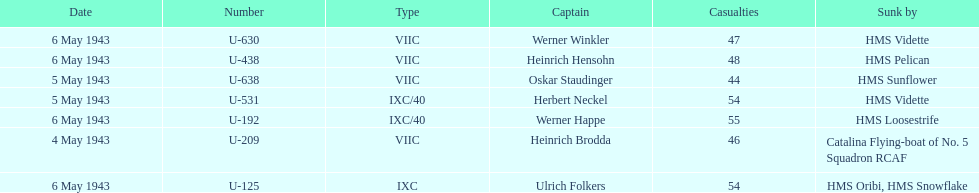Which ship sunk the most u-boats HMS Vidette. 